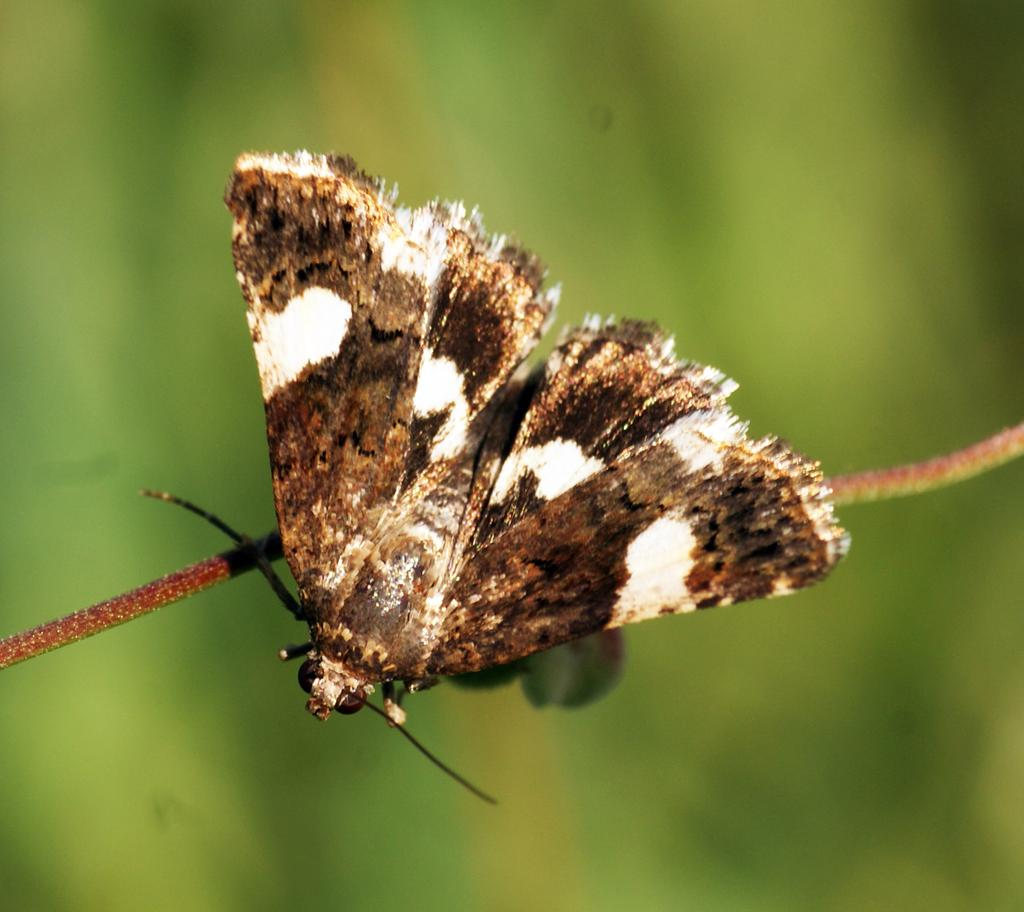What type of creature is present in the image? There is an insect in the image. Can you describe the colors of the insect? The insect has brown and white colors. Where is the insect located in the image? The insect is on a rope. What can be seen in the background of the image? The background of the image is green. What type of blade is being used to cut the rope in the image? There is no blade or rope-cutting activity present in the image. 